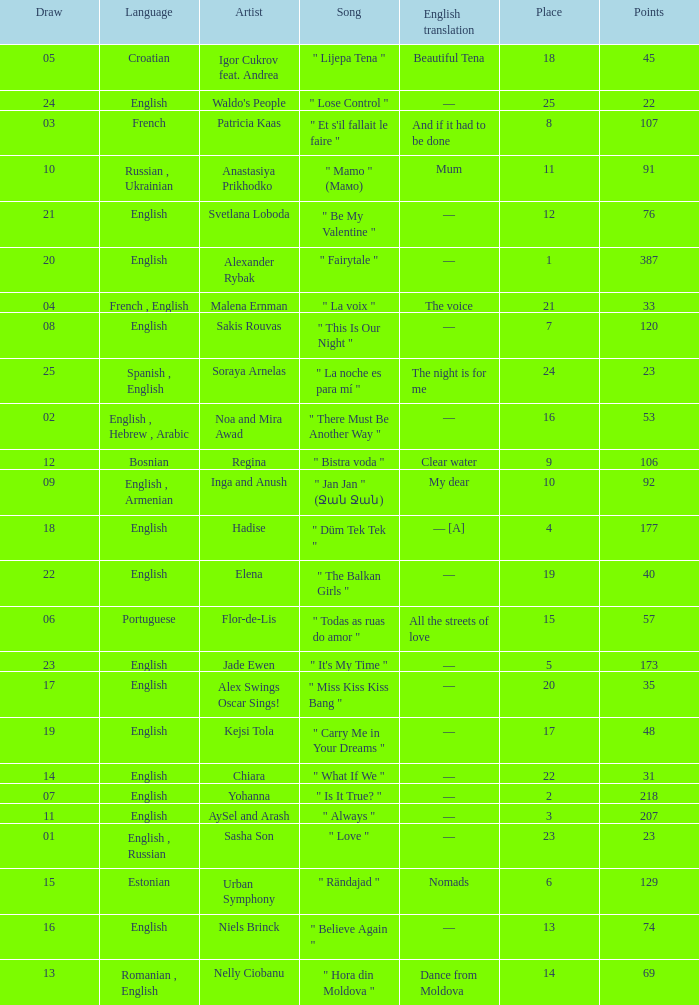What was the english translation for the song by svetlana loboda? —. 